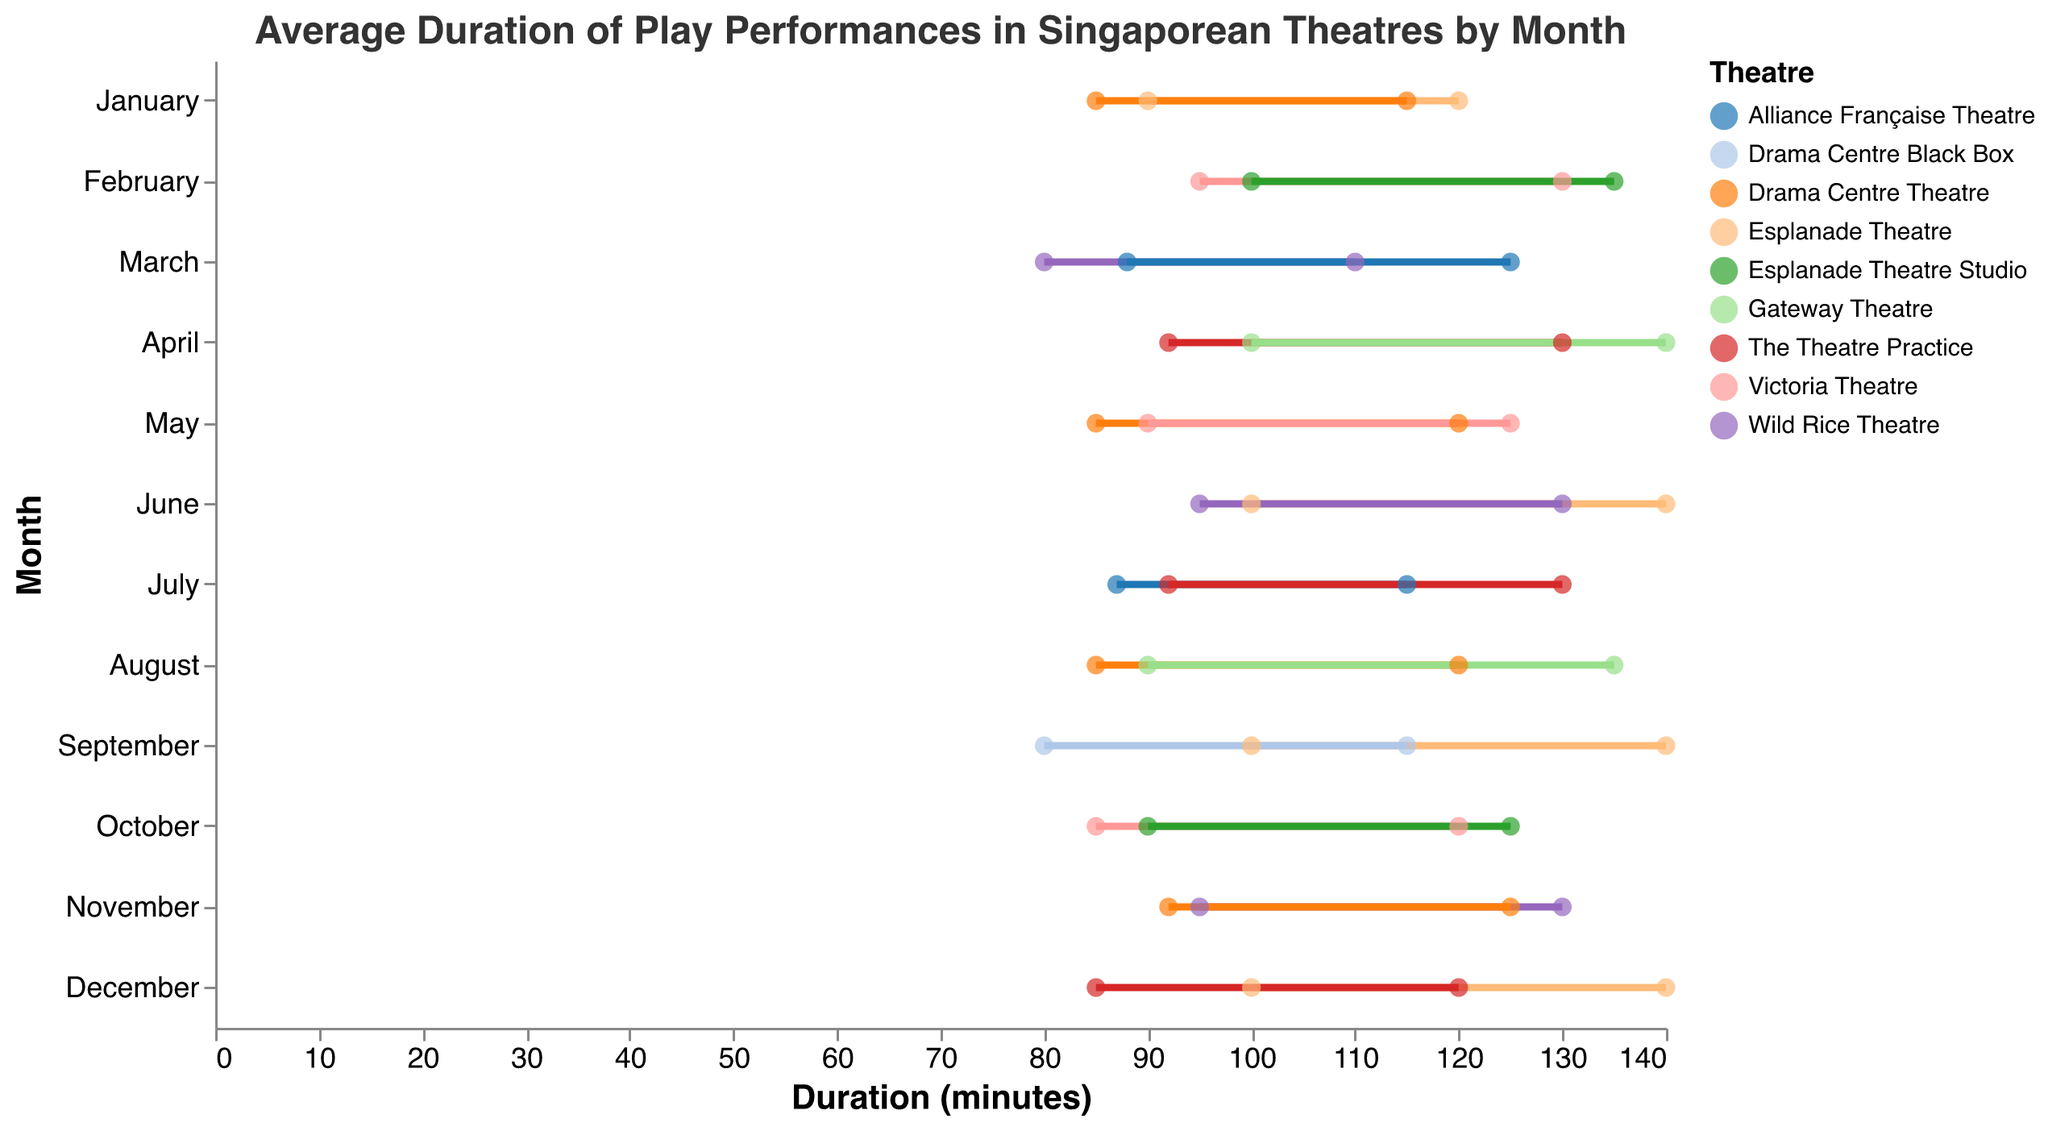What is the title of the plot? The title is typically presented at the top of the figure. It reads: "Average Duration of Play Performances in Singaporean Theatres by Month."
Answer: Average Duration of Play Performances in Singaporean Theatres by Month Which theatre has the widest range of play durations in April? Identify the range by subtracting the minimum duration from the maximum duration for each theatre in April. The Theatre Practice has a range of 130 - 92 = 38 minutes, while Gateway Theatre has a range of 140 - 100 = 40 minutes.
Answer: Gateway Theatre How does the average maximum duration in August at Gateway Theatre compare to that at Drama Centre Theatre? The average maximum duration in August at Gateway Theatre is 135 minutes and at Drama Centre Theatre is 120 minutes. 135 is greater than 120, so Gateway Theatre's duration is longer.
Answer: Gateway Theatre's duration is longer Which month has the lowest average minimum duration, and at which theatre? Look through the plot to find the lowest value on the lower bound of the duration for each month. The lowest is in March at Wild Rice Theatre with 80 minutes.
Answer: March at Wild Rice Theatre What are the average minimum and maximum durations for Esplanade Theatre in June? Locate Esplanade Theatre for the month of June and identify the points on the plot. The values are 100 minutes for minimum and 140 minutes for maximum.
Answer: 100 and 140 minutes For which month and theatre does the maximum duration hit exactly 115 minutes? Scan through each month and theatre to find the points where the maximum duration touches 115 minutes. January at Drama Centre Theatre and September at Drama Centre Black Box both have maximum durations of 115 minutes.
Answer: January at Drama Centre Theatre and September at Drama Centre Black Box What is the difference in average minimum duration between September at Esplanade Theatre and September at Drama Centre Black Box? Find the average minimum duration for both theatres in September: Esplanade Theatre is 100 minutes, Drama Centre Black Box is 80 minutes. The difference is 100 - 80 = 20 minutes.
Answer: 20 minutes Overall, which theatre appears most consistently across different months? Identify the theatre names and count their occurrences in different months. Esplanade Theatre appears in January, June, September, and December, marking it as recurring frequently.
Answer: Esplanade Theatre What's the maximum range of durations for any theatre across the dataset? Calculate the ranges for all theatre entries: maximum range is 140 - 80 = 60 minutes for multiple theatres including Gateway Theatre (April, June, December).
Answer: 60 minutes What is the average maximum duration for May across all theatres? Identify and add the maximum durations for May: Drama Centre Theatre (120) and Victoria Theatre (125). Their values sum to 245. The average is 245 / 2 = 122.5 minutes.
Answer: 122.5 minutes 